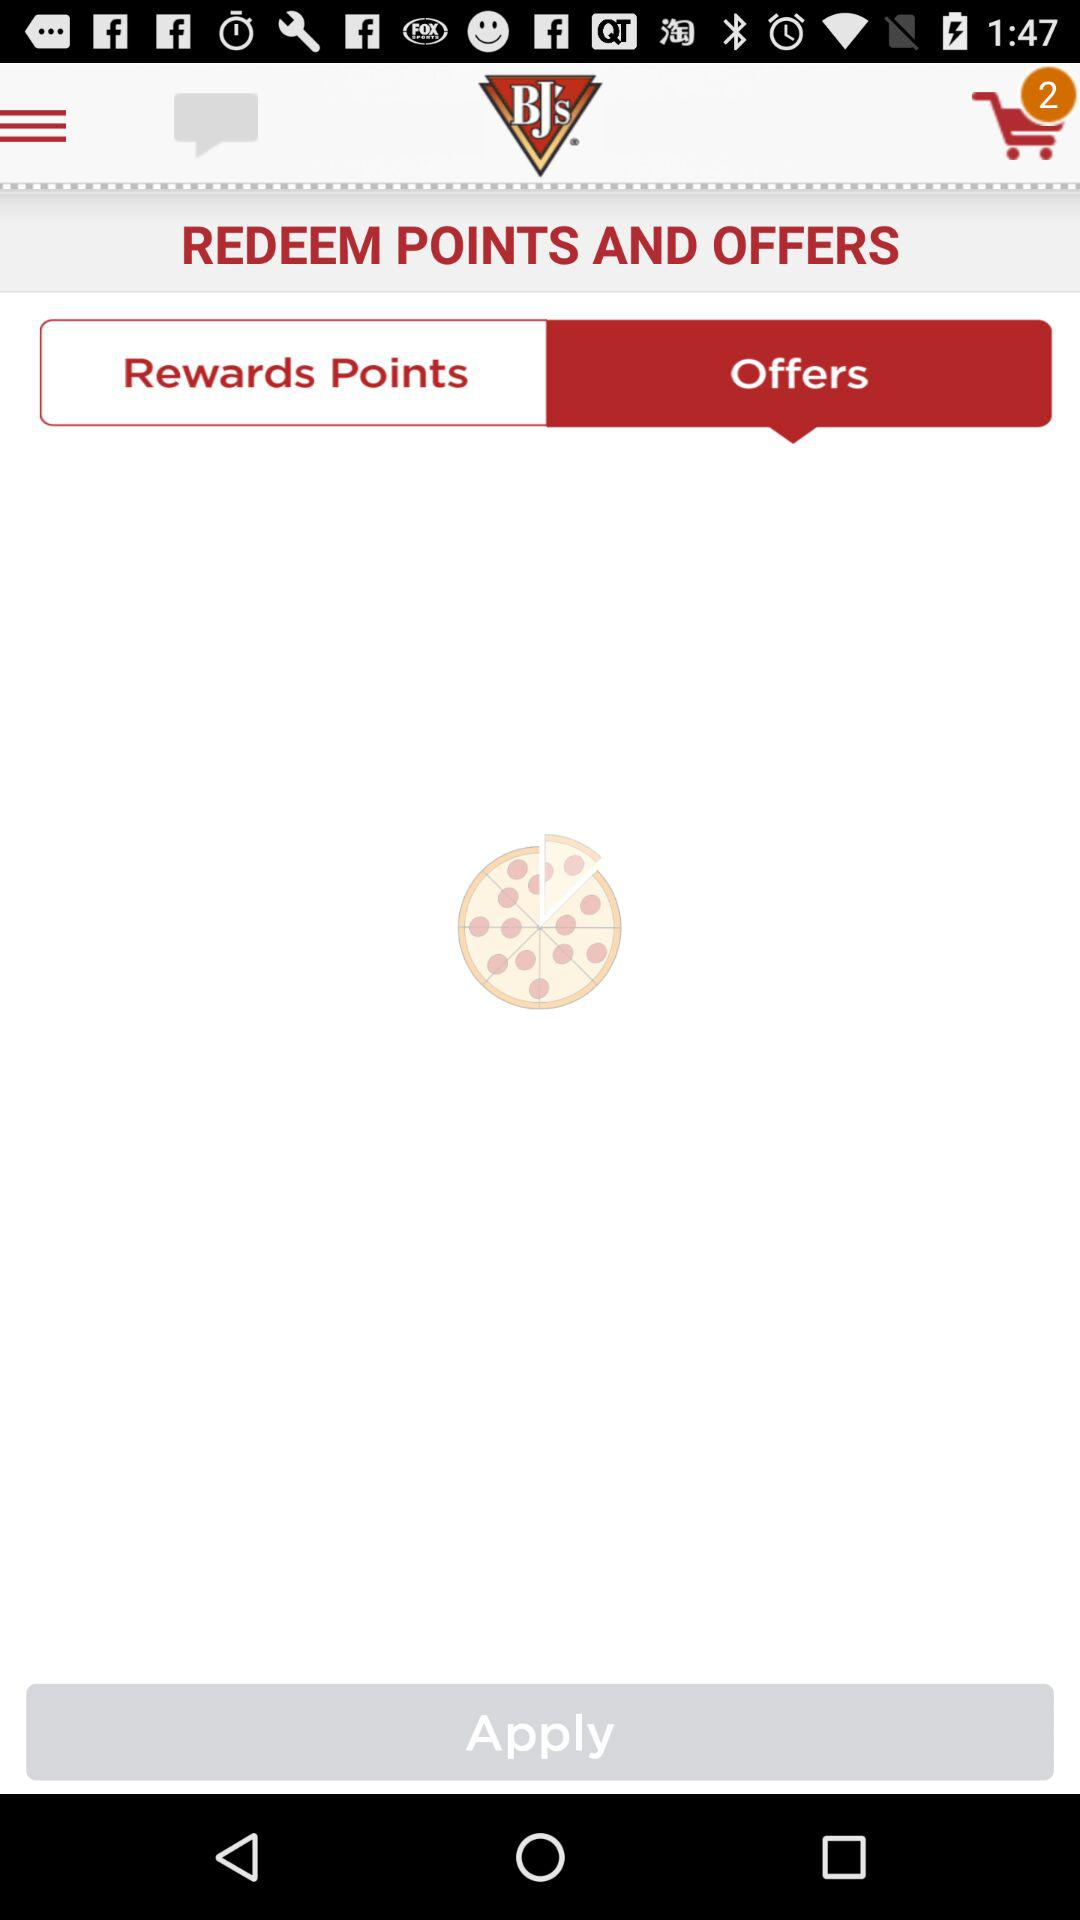How many items are in the cart? There are 2 items in the cart. 